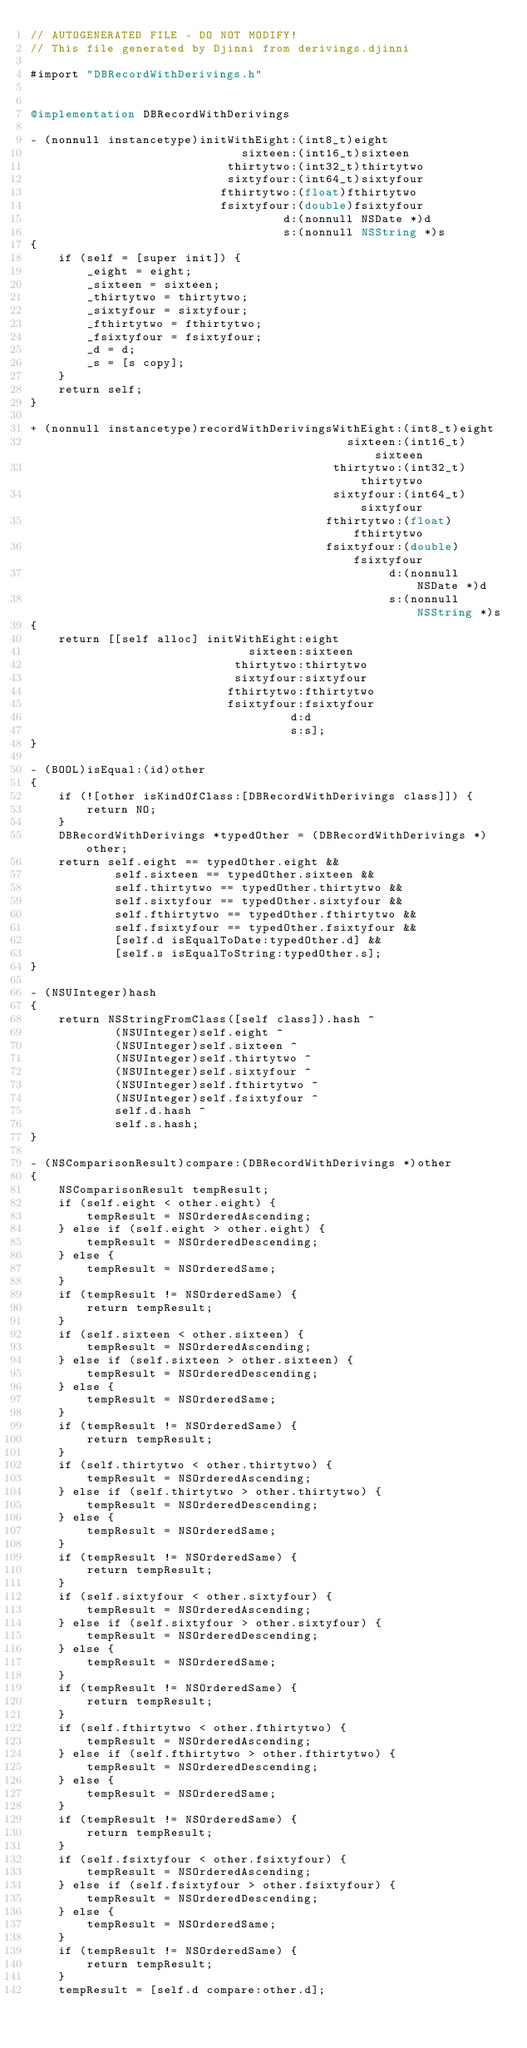Convert code to text. <code><loc_0><loc_0><loc_500><loc_500><_ObjectiveC_>// AUTOGENERATED FILE - DO NOT MODIFY!
// This file generated by Djinni from derivings.djinni

#import "DBRecordWithDerivings.h"


@implementation DBRecordWithDerivings

- (nonnull instancetype)initWithEight:(int8_t)eight
                              sixteen:(int16_t)sixteen
                            thirtytwo:(int32_t)thirtytwo
                            sixtyfour:(int64_t)sixtyfour
                           fthirtytwo:(float)fthirtytwo
                           fsixtyfour:(double)fsixtyfour
                                    d:(nonnull NSDate *)d
                                    s:(nonnull NSString *)s
{
    if (self = [super init]) {
        _eight = eight;
        _sixteen = sixteen;
        _thirtytwo = thirtytwo;
        _sixtyfour = sixtyfour;
        _fthirtytwo = fthirtytwo;
        _fsixtyfour = fsixtyfour;
        _d = d;
        _s = [s copy];
    }
    return self;
}

+ (nonnull instancetype)recordWithDerivingsWithEight:(int8_t)eight
                                             sixteen:(int16_t)sixteen
                                           thirtytwo:(int32_t)thirtytwo
                                           sixtyfour:(int64_t)sixtyfour
                                          fthirtytwo:(float)fthirtytwo
                                          fsixtyfour:(double)fsixtyfour
                                                   d:(nonnull NSDate *)d
                                                   s:(nonnull NSString *)s
{
    return [[self alloc] initWithEight:eight
                               sixteen:sixteen
                             thirtytwo:thirtytwo
                             sixtyfour:sixtyfour
                            fthirtytwo:fthirtytwo
                            fsixtyfour:fsixtyfour
                                     d:d
                                     s:s];
}

- (BOOL)isEqual:(id)other
{
    if (![other isKindOfClass:[DBRecordWithDerivings class]]) {
        return NO;
    }
    DBRecordWithDerivings *typedOther = (DBRecordWithDerivings *)other;
    return self.eight == typedOther.eight &&
            self.sixteen == typedOther.sixteen &&
            self.thirtytwo == typedOther.thirtytwo &&
            self.sixtyfour == typedOther.sixtyfour &&
            self.fthirtytwo == typedOther.fthirtytwo &&
            self.fsixtyfour == typedOther.fsixtyfour &&
            [self.d isEqualToDate:typedOther.d] &&
            [self.s isEqualToString:typedOther.s];
}

- (NSUInteger)hash
{
    return NSStringFromClass([self class]).hash ^
            (NSUInteger)self.eight ^
            (NSUInteger)self.sixteen ^
            (NSUInteger)self.thirtytwo ^
            (NSUInteger)self.sixtyfour ^
            (NSUInteger)self.fthirtytwo ^
            (NSUInteger)self.fsixtyfour ^
            self.d.hash ^
            self.s.hash;
}

- (NSComparisonResult)compare:(DBRecordWithDerivings *)other
{
    NSComparisonResult tempResult;
    if (self.eight < other.eight) {
        tempResult = NSOrderedAscending;
    } else if (self.eight > other.eight) {
        tempResult = NSOrderedDescending;
    } else {
        tempResult = NSOrderedSame;
    }
    if (tempResult != NSOrderedSame) {
        return tempResult;
    }
    if (self.sixteen < other.sixteen) {
        tempResult = NSOrderedAscending;
    } else if (self.sixteen > other.sixteen) {
        tempResult = NSOrderedDescending;
    } else {
        tempResult = NSOrderedSame;
    }
    if (tempResult != NSOrderedSame) {
        return tempResult;
    }
    if (self.thirtytwo < other.thirtytwo) {
        tempResult = NSOrderedAscending;
    } else if (self.thirtytwo > other.thirtytwo) {
        tempResult = NSOrderedDescending;
    } else {
        tempResult = NSOrderedSame;
    }
    if (tempResult != NSOrderedSame) {
        return tempResult;
    }
    if (self.sixtyfour < other.sixtyfour) {
        tempResult = NSOrderedAscending;
    } else if (self.sixtyfour > other.sixtyfour) {
        tempResult = NSOrderedDescending;
    } else {
        tempResult = NSOrderedSame;
    }
    if (tempResult != NSOrderedSame) {
        return tempResult;
    }
    if (self.fthirtytwo < other.fthirtytwo) {
        tempResult = NSOrderedAscending;
    } else if (self.fthirtytwo > other.fthirtytwo) {
        tempResult = NSOrderedDescending;
    } else {
        tempResult = NSOrderedSame;
    }
    if (tempResult != NSOrderedSame) {
        return tempResult;
    }
    if (self.fsixtyfour < other.fsixtyfour) {
        tempResult = NSOrderedAscending;
    } else if (self.fsixtyfour > other.fsixtyfour) {
        tempResult = NSOrderedDescending;
    } else {
        tempResult = NSOrderedSame;
    }
    if (tempResult != NSOrderedSame) {
        return tempResult;
    }
    tempResult = [self.d compare:other.d];</code> 